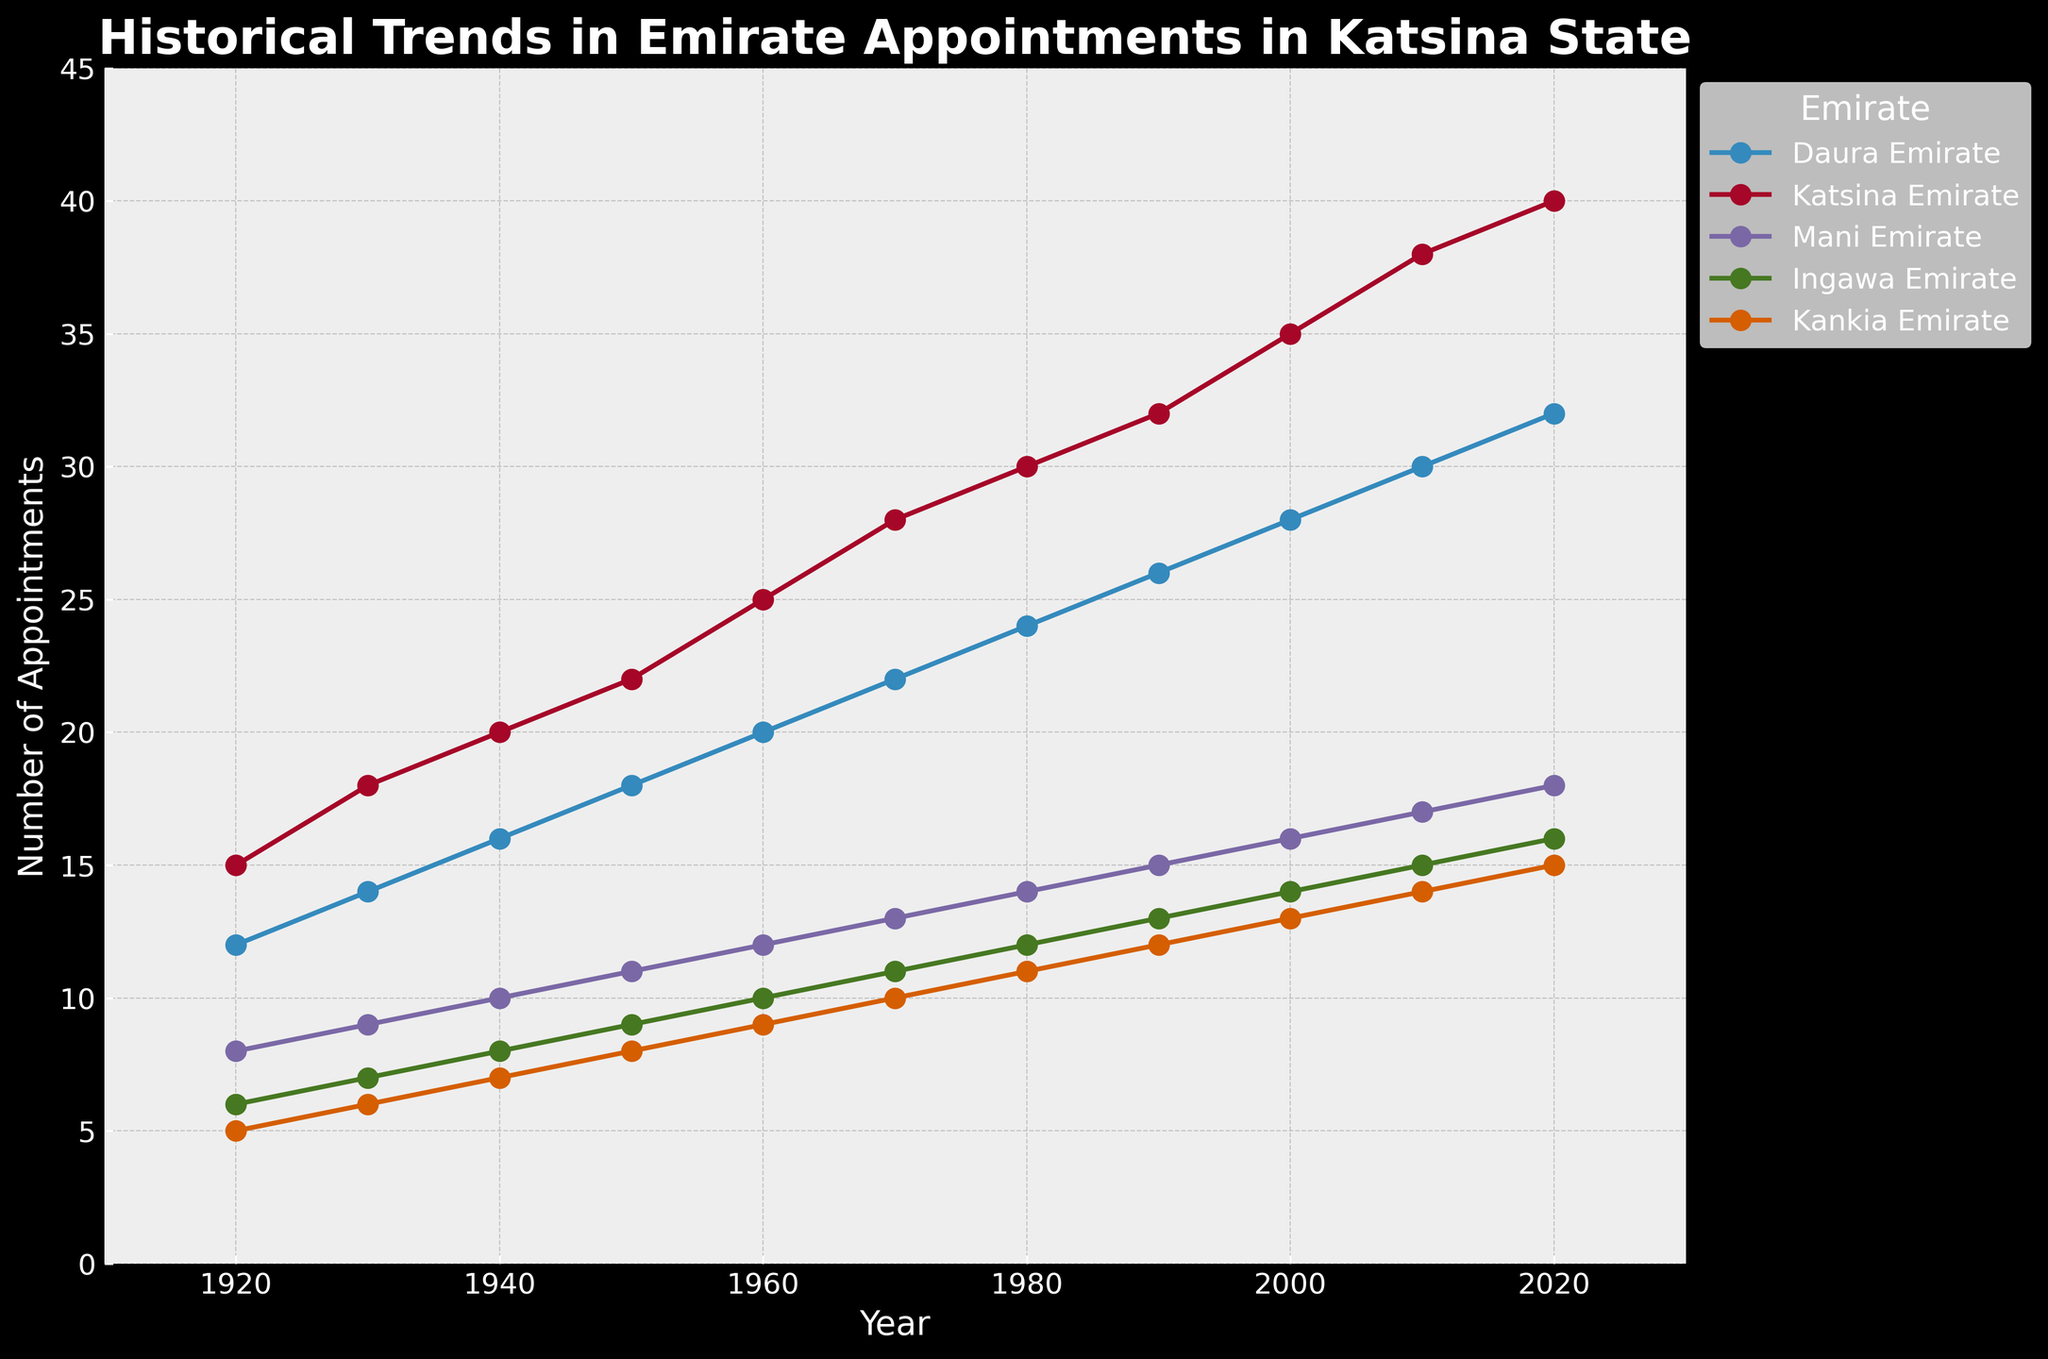Which Emirate had the highest number of appointments in 2020? By looking at the end points of the year 2020 on the x-axis and then examining the corresponding y-axis values, Katsina Emirate has the highest number, which is 40.
Answer: Katsina Emirate How many total appointments were made across all emirates in 1960? Sum the number of appointments for each emirate in 1960: Daura (20) + Katsina (25) + Mani (12) + Ingawa (10) + Kankia (9) = 76.
Answer: 76 By what amount did the number of appointments in Ingawa Emirate grow from 1930 to 1950? Subtract the number of appointments in 1930 (7) from the number in 1950 (9): 9 - 7 = 2.
Answer: 2 Which emirate had the smallest increase in appointments from 1920 to 2020? Calculate the difference in appointments for each emirate between 1920 and 2020: Daura (32-12), Katsina (40-15), Mani (18-8), Ingawa (16-6), Kankia (15-5). Kankia Emirate has the smallest increase: 10.
Answer: Kankia Emirate In which decade did Daura Emirate see the highest growth in appointments? By comparing the changes in the number of appointments for each decade: 1930 (14-12=2), 1940 (16-14=2), 1950 (18-16=2), 1960 (20-18=2), 1970 (22-20=2), 1980 (24-22=2), 1990 (26-24=2), 2000 (28-26=2), 2010 (30-28=2), 2020 (32-30=2), the growth is constant at 2 appointments per decade.
Answer: All decades (growth of 2) Which two emirates had an equal number of appointments in 1980? By looking carefully at the data points for each emirate in 1980, Mani Emirate and Ingawa Emirate both had 14 appointments.
Answer: Mani Emirate and Ingawa Emirate How much higher was the number of appointments in Katsina Emirate than Mani Emirate in the year 2000? Subtract the number of appointments in Mani (16) from Katsina (35): 35 - 16 = 19.
Answer: 19 During which decade did Kankia Emirate see an increase that took its appointments into double digits? Kankia Emirate crossed into double digits in the 1970s as it had 10 appointments in 1970 and below 10 before this decade.
Answer: 1970s What is the average number of appointments across all emirates in 1940? Sum the number of appointments in 1940 and divide by the number of emirates: (16 + 20 + 10 + 8 + 7)/5 = 61/5 = 12.2.
Answer: 12.2 Between which two decades did Katsina Emirate see the largest increase in appointments? By comparing changes in appointments across each decade for Katsina: 1930 (18-15=3), 1940 (20-18=2), 1950 (22-20=2), 1960 (25-22=3), 1970 (28-25=3), 1980 (30-28=2), 1990 (32-30=2), 2000 (35-32=3), 2010 (38-35=3), 2020 (40-38=2), the largest increase between two decades is 3 (multiple decades have the same increase).
Answer: 1930-1940 and other similar pairs 